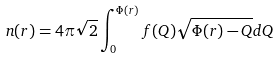<formula> <loc_0><loc_0><loc_500><loc_500>n ( r ) = 4 \pi \sqrt { 2 } \int _ { 0 } ^ { \Phi ( r ) } f ( Q ) \sqrt { \Phi ( r ) - Q } d Q</formula> 